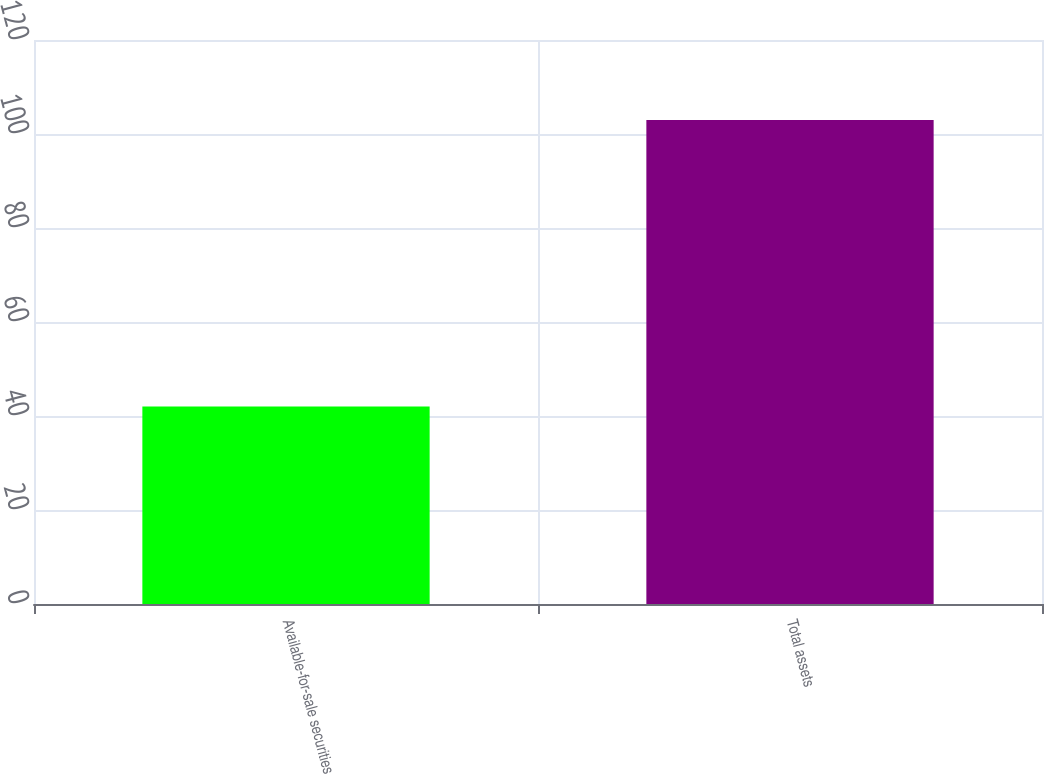Convert chart. <chart><loc_0><loc_0><loc_500><loc_500><bar_chart><fcel>Available-for-sale securities<fcel>Total assets<nl><fcel>42<fcel>103<nl></chart> 